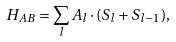Convert formula to latex. <formula><loc_0><loc_0><loc_500><loc_500>H _ { A B } = \sum _ { l } A _ { l } \cdot ( S _ { l } + S _ { l - 1 } ) ,</formula> 